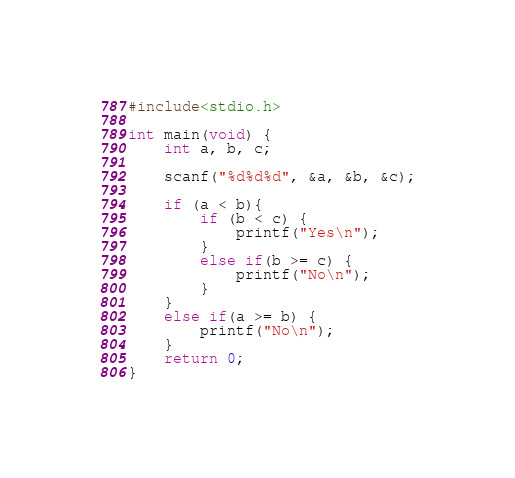<code> <loc_0><loc_0><loc_500><loc_500><_C_>#include<stdio.h>

int main(void) {
	int a, b, c;

	scanf("%d%d%d", &a, &b, &c);

	if (a < b){
		if (b < c) {
			printf("Yes\n");
		}
		else if(b >= c) {
			printf("No\n");
		}
	}
	else if(a >= b) {
		printf("No\n");
	}
	return 0;
}</code> 